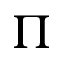<formula> <loc_0><loc_0><loc_500><loc_500>\Pi</formula> 